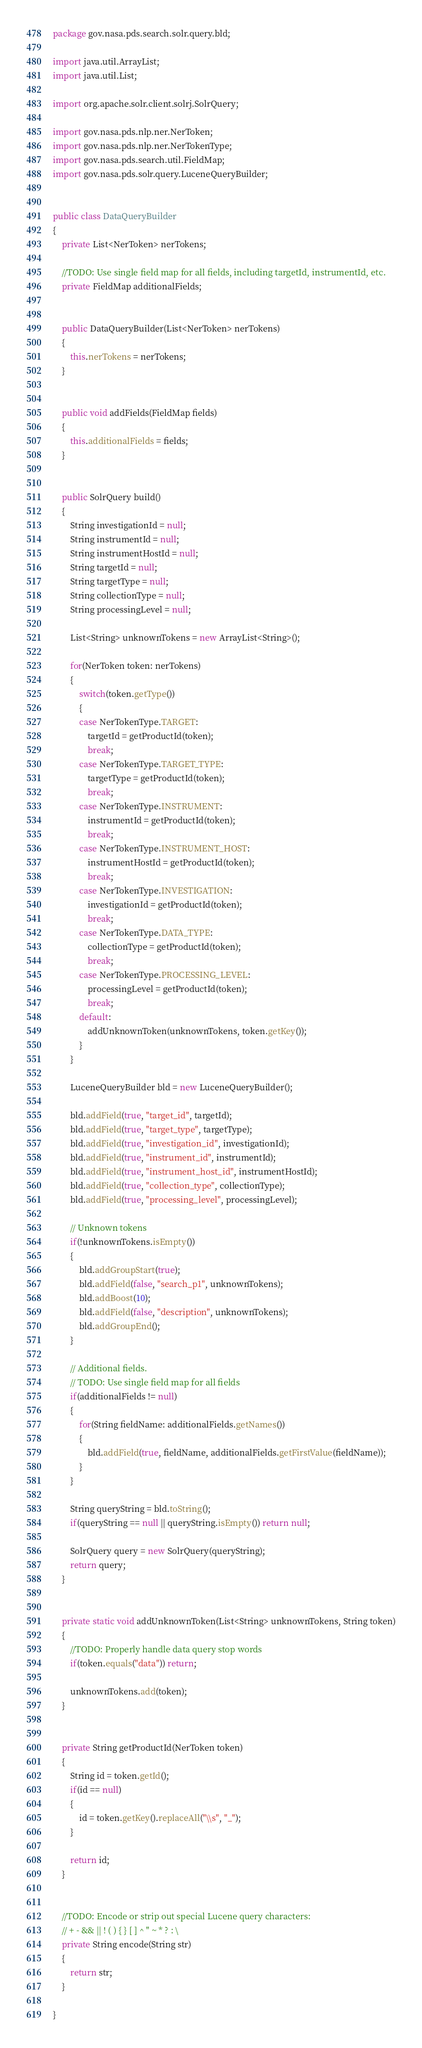<code> <loc_0><loc_0><loc_500><loc_500><_Java_>package gov.nasa.pds.search.solr.query.bld;

import java.util.ArrayList;
import java.util.List;

import org.apache.solr.client.solrj.SolrQuery;

import gov.nasa.pds.nlp.ner.NerToken;
import gov.nasa.pds.nlp.ner.NerTokenType;
import gov.nasa.pds.search.util.FieldMap;
import gov.nasa.pds.solr.query.LuceneQueryBuilder;


public class DataQueryBuilder
{
    private List<NerToken> nerTokens;
    
    //TODO: Use single field map for all fields, including targetId, instrumentId, etc.
    private FieldMap additionalFields;
    
    
    public DataQueryBuilder(List<NerToken> nerTokens)
    {
        this.nerTokens = nerTokens;
    }


    public void addFields(FieldMap fields)
    {
        this.additionalFields = fields; 
    }


    public SolrQuery build()
    {
        String investigationId = null;
        String instrumentId = null;
        String instrumentHostId = null;
        String targetId = null;
        String targetType = null;
        String collectionType = null;
        String processingLevel = null;
        
        List<String> unknownTokens = new ArrayList<String>();
        
        for(NerToken token: nerTokens)
        {
            switch(token.getType())
            {
            case NerTokenType.TARGET:
                targetId = getProductId(token);
                break;
            case NerTokenType.TARGET_TYPE:
                targetType = getProductId(token);
                break;
            case NerTokenType.INSTRUMENT:
                instrumentId = getProductId(token);
                break;
            case NerTokenType.INSTRUMENT_HOST:
                instrumentHostId = getProductId(token);
                break;
            case NerTokenType.INVESTIGATION:
                investigationId = getProductId(token);
                break;
            case NerTokenType.DATA_TYPE:
                collectionType = getProductId(token);
                break;
            case NerTokenType.PROCESSING_LEVEL:
                processingLevel = getProductId(token);
                break;
            default:
                addUnknownToken(unknownTokens, token.getKey());
            }
        }

        LuceneQueryBuilder bld = new LuceneQueryBuilder();
        
        bld.addField(true, "target_id", targetId);
        bld.addField(true, "target_type", targetType);
        bld.addField(true, "investigation_id", investigationId);
        bld.addField(true, "instrument_id", instrumentId);
        bld.addField(true, "instrument_host_id", instrumentHostId);
        bld.addField(true, "collection_type", collectionType);
        bld.addField(true, "processing_level", processingLevel);

        // Unknown tokens
        if(!unknownTokens.isEmpty())
        {
            bld.addGroupStart(true);
            bld.addField(false, "search_p1", unknownTokens);
            bld.addBoost(10);
            bld.addField(false, "description", unknownTokens);
            bld.addGroupEnd();
        }

        // Additional fields.
        // TODO: Use single field map for all fields
        if(additionalFields != null)
        {
            for(String fieldName: additionalFields.getNames())
            {
                bld.addField(true, fieldName, additionalFields.getFirstValue(fieldName));
            }
        }
        
        String queryString = bld.toString();
        if(queryString == null || queryString.isEmpty()) return null;
        
        SolrQuery query = new SolrQuery(queryString);
        return query;
    }
    
    
    private static void addUnknownToken(List<String> unknownTokens, String token)
    {
        //TODO: Properly handle data query stop words
        if(token.equals("data")) return;
        
        unknownTokens.add(token);
    }
    
    
    private String getProductId(NerToken token)
    {
        String id = token.getId();
        if(id == null) 
        {
            id = token.getKey().replaceAll("\\s", "_");
        }
        
        return id;
    }
    
    
    //TODO: Encode or strip out special Lucene query characters:
    // + - && || ! ( ) { } [ ] ^ " ~ * ? : \
    private String encode(String str)
    {
        return str;
    }
    
}
</code> 